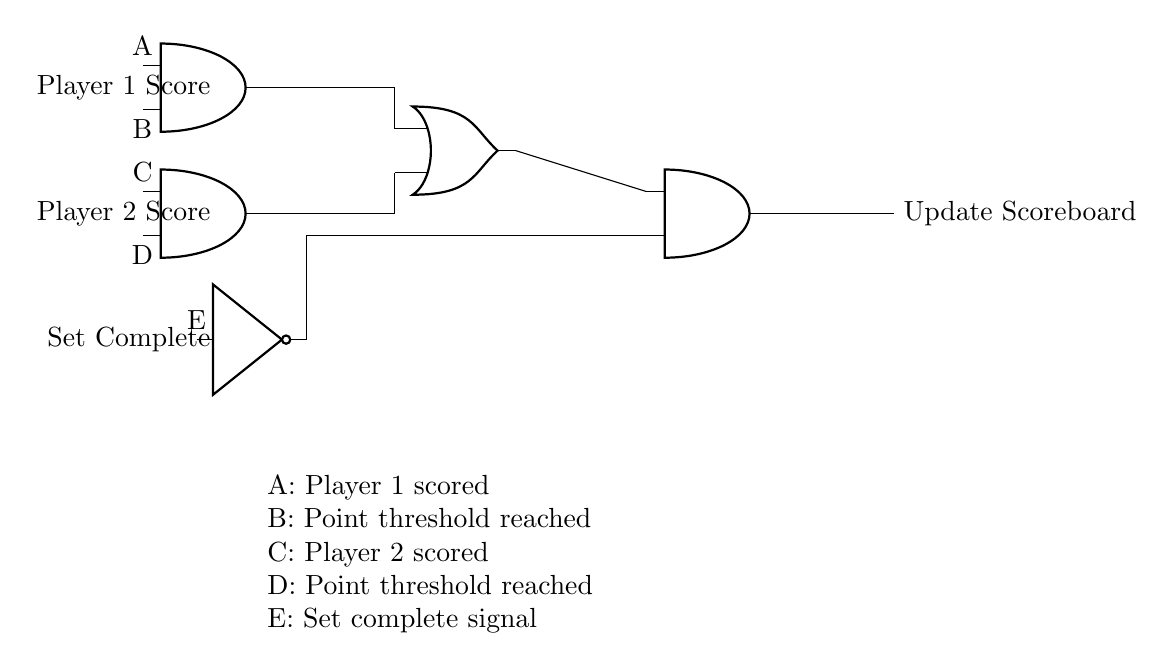What is the output of the circuit? The output of the circuit is the signal labeled "Update Scoreboard" which reflects changes in player scores based on input conditions.
Answer: Update Scoreboard Which logic gate is used to display Player 1's score? Player 1's score is processed through the AND gate (labeled A and B), which combines the necessary conditions for the score update.
Answer: AND gate What does the NOT gate represent in the circuit? The NOT gate in the circuit represents the inversion of the "Set Complete" signal, affecting how scores are updated when the set is complete.
Answer: Inversion of Set Complete How many AND gates are present in the circuit? The circuit includes three AND gates: one for Player 1, one for Player 2, and one that combines signals before updating the scoreboard.
Answer: Three What is the role of the OR gate in this circuit? The OR gate takes the outputs from the two AND gates corresponding to both players and determines if either player has scored based on the defined conditions.
Answer: Determine scoring When does the scoreboard get updated? The scoreboard gets updated when either player's score conditions are satisfied, as indicated by the output from the final AND gate after processing through the OR gate and the NOT gate.
Answer: When conditions are met 